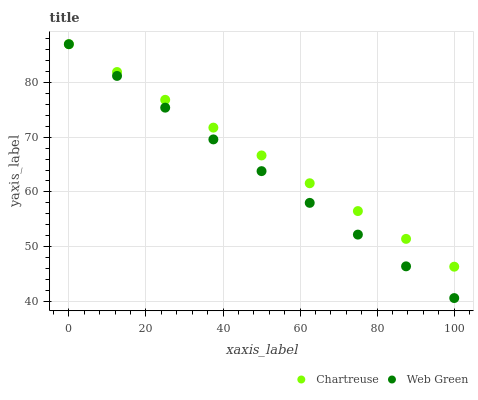Does Web Green have the minimum area under the curve?
Answer yes or no. Yes. Does Chartreuse have the maximum area under the curve?
Answer yes or no. Yes. Does Web Green have the maximum area under the curve?
Answer yes or no. No. Is Web Green the smoothest?
Answer yes or no. Yes. Is Chartreuse the roughest?
Answer yes or no. Yes. Is Web Green the roughest?
Answer yes or no. No. Does Web Green have the lowest value?
Answer yes or no. Yes. Does Web Green have the highest value?
Answer yes or no. Yes. Does Web Green intersect Chartreuse?
Answer yes or no. Yes. Is Web Green less than Chartreuse?
Answer yes or no. No. Is Web Green greater than Chartreuse?
Answer yes or no. No. 